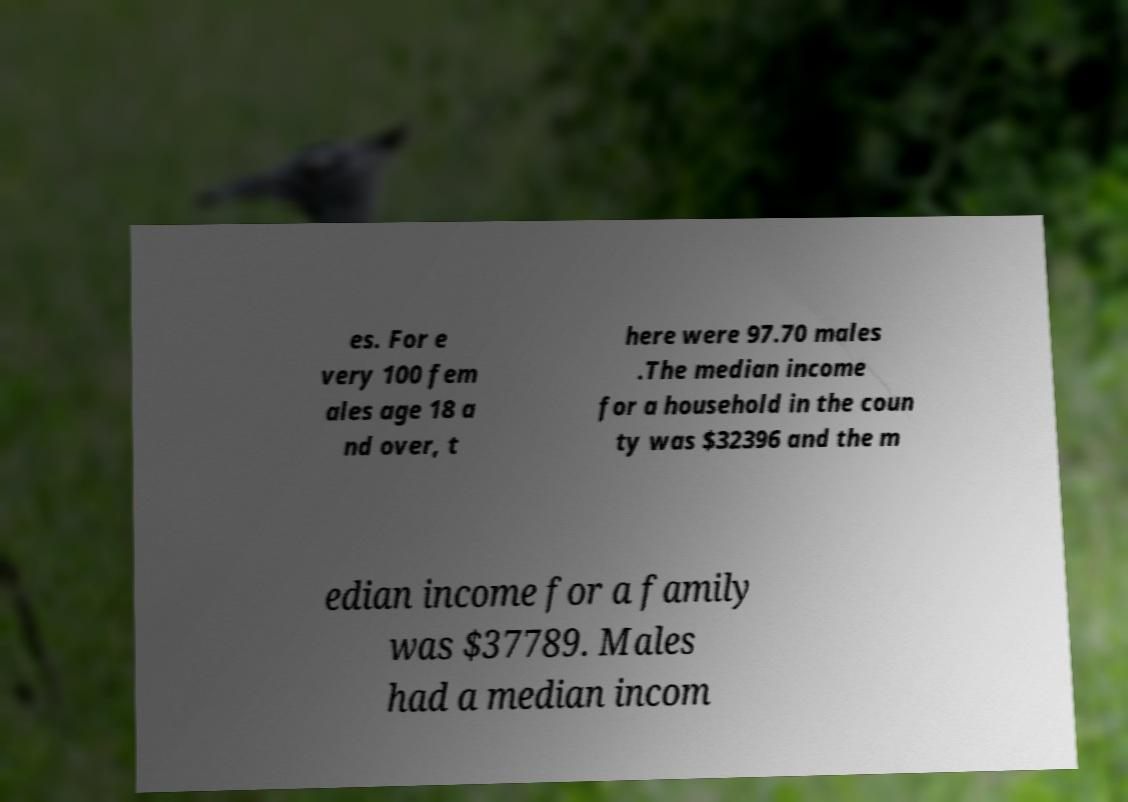I need the written content from this picture converted into text. Can you do that? es. For e very 100 fem ales age 18 a nd over, t here were 97.70 males .The median income for a household in the coun ty was $32396 and the m edian income for a family was $37789. Males had a median incom 